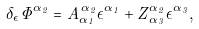<formula> <loc_0><loc_0><loc_500><loc_500>\delta _ { \epsilon } \Phi ^ { \alpha _ { 2 } } = A _ { \alpha _ { 1 } } ^ { \, \alpha _ { 2 } } \epsilon ^ { \alpha _ { 1 } } + Z _ { \, \alpha _ { 3 } } ^ { \alpha _ { 2 } } \epsilon ^ { \alpha _ { 3 } } ,</formula> 